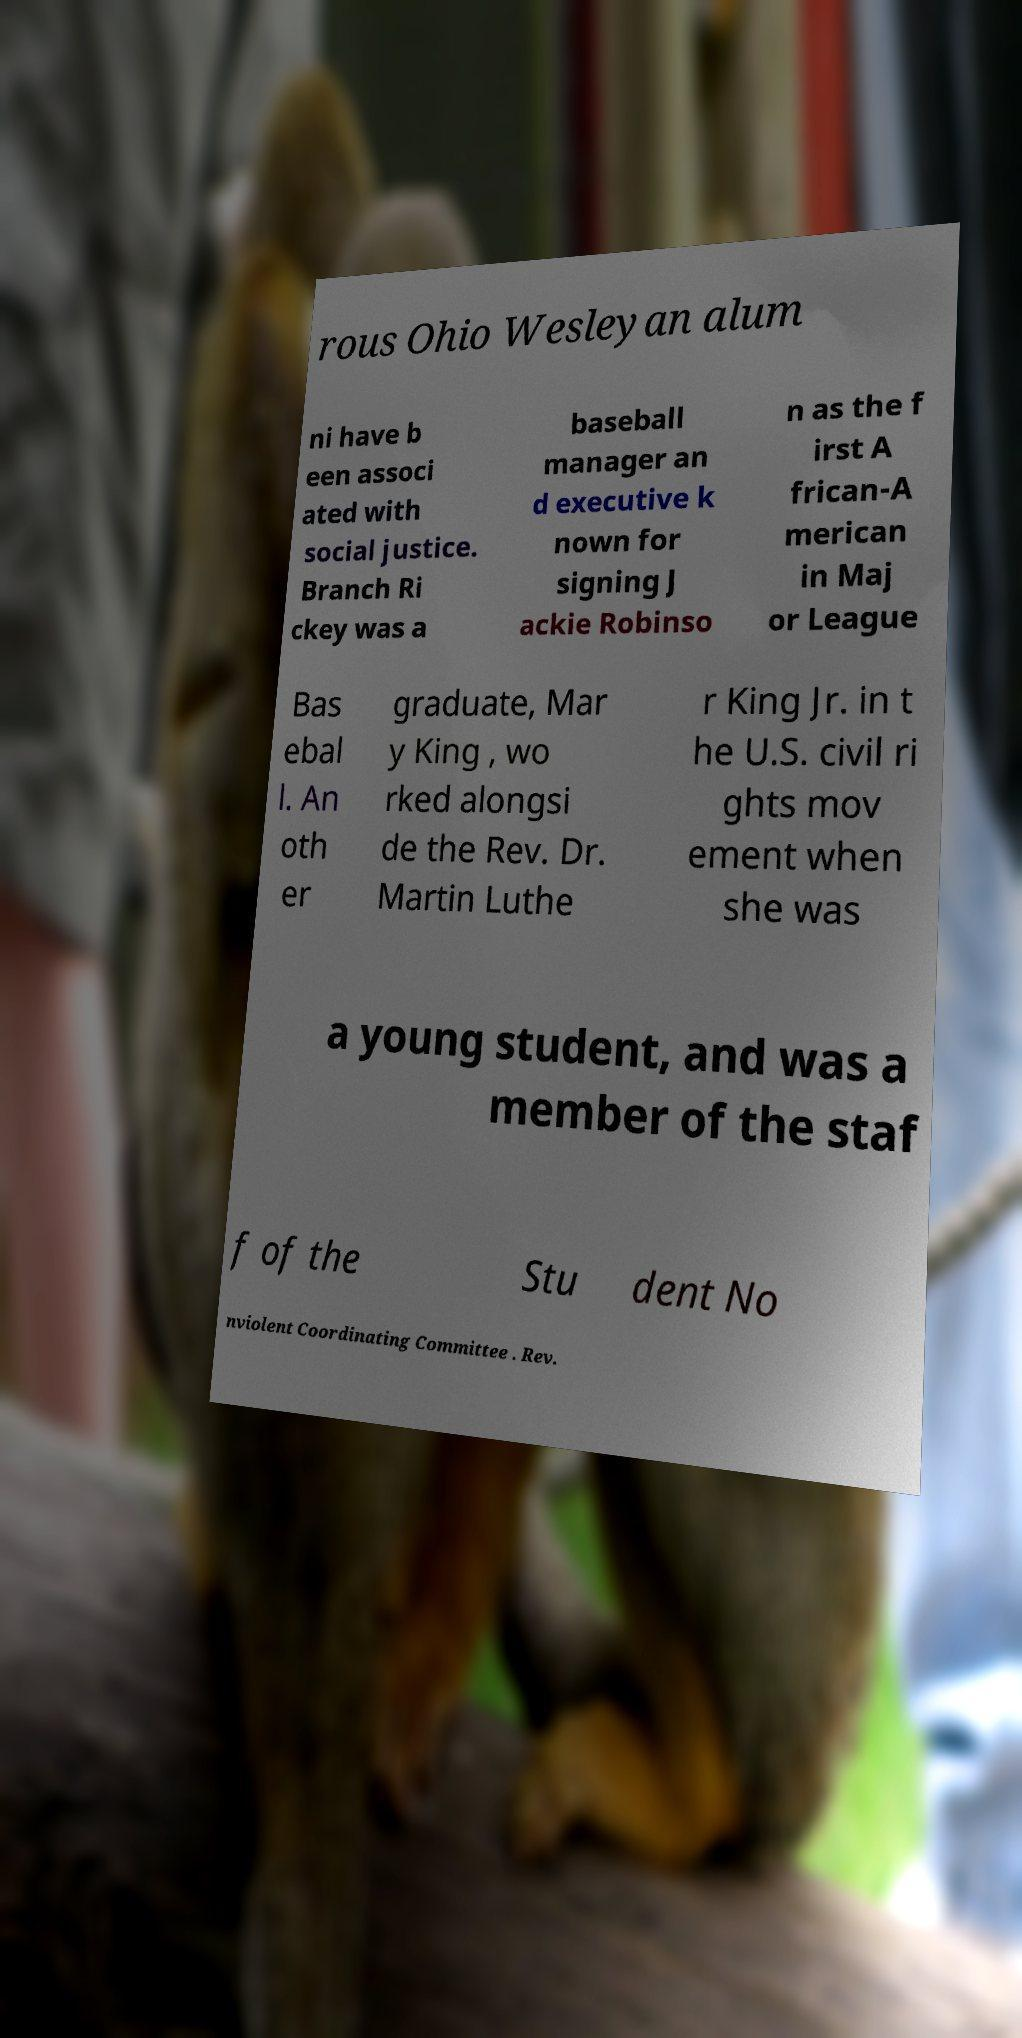Could you assist in decoding the text presented in this image and type it out clearly? rous Ohio Wesleyan alum ni have b een associ ated with social justice. Branch Ri ckey was a baseball manager an d executive k nown for signing J ackie Robinso n as the f irst A frican-A merican in Maj or League Bas ebal l. An oth er graduate, Mar y King , wo rked alongsi de the Rev. Dr. Martin Luthe r King Jr. in t he U.S. civil ri ghts mov ement when she was a young student, and was a member of the staf f of the Stu dent No nviolent Coordinating Committee . Rev. 